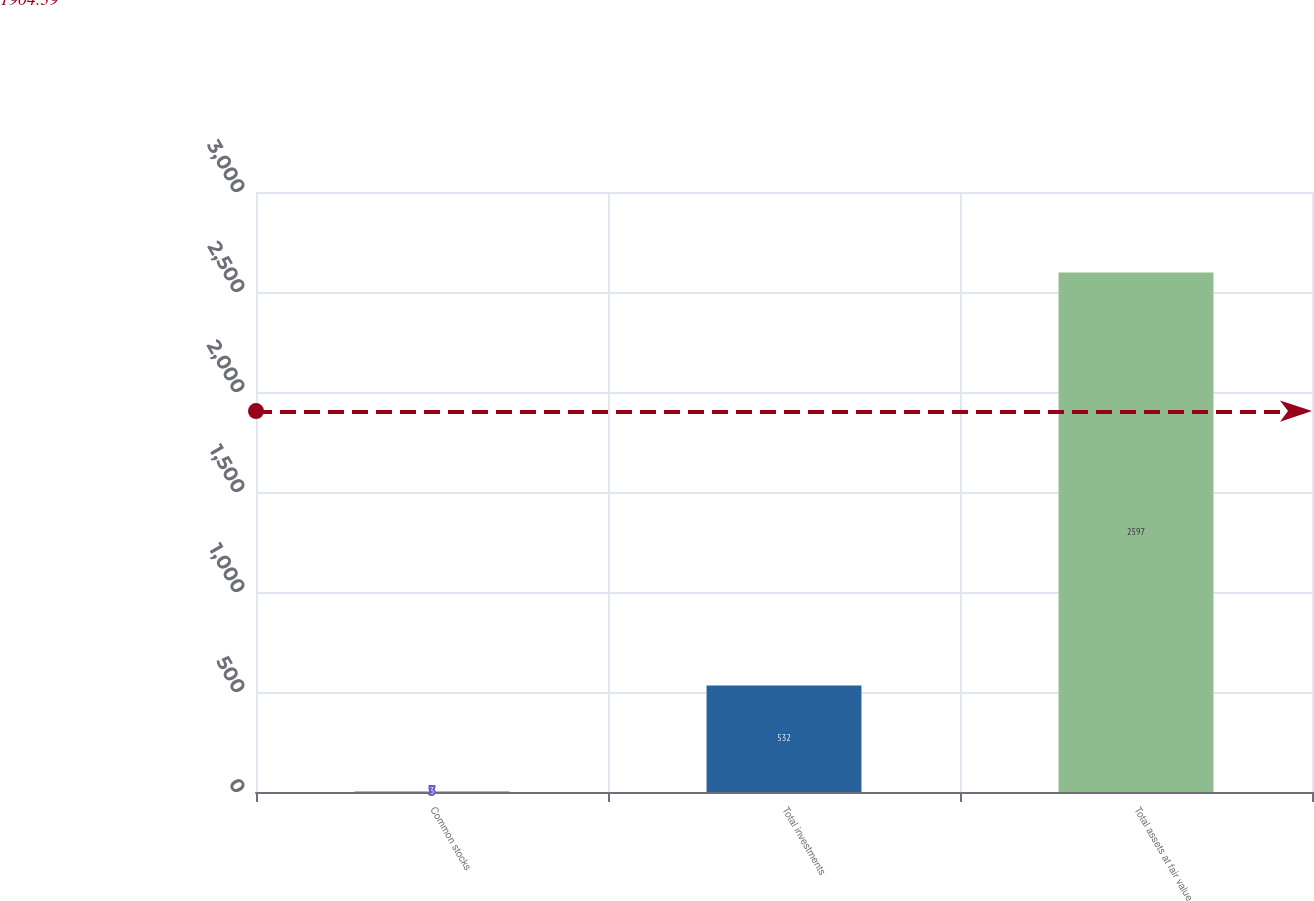Convert chart to OTSL. <chart><loc_0><loc_0><loc_500><loc_500><bar_chart><fcel>Common stocks<fcel>Total investments<fcel>Total assets at fair value<nl><fcel>3<fcel>532<fcel>2597<nl></chart> 